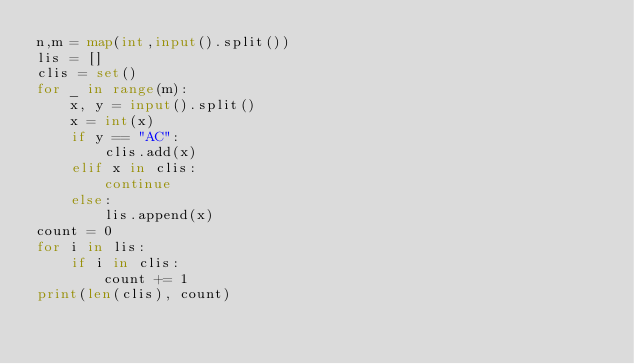Convert code to text. <code><loc_0><loc_0><loc_500><loc_500><_Python_>n,m = map(int,input().split())
lis = []
clis = set()
for _ in range(m):
    x, y = input().split()
    x = int(x)
    if y == "AC":
        clis.add(x)
    elif x in clis:
        continue
    else:
        lis.append(x)
count = 0
for i in lis:
    if i in clis:
        count += 1
print(len(clis), count)</code> 